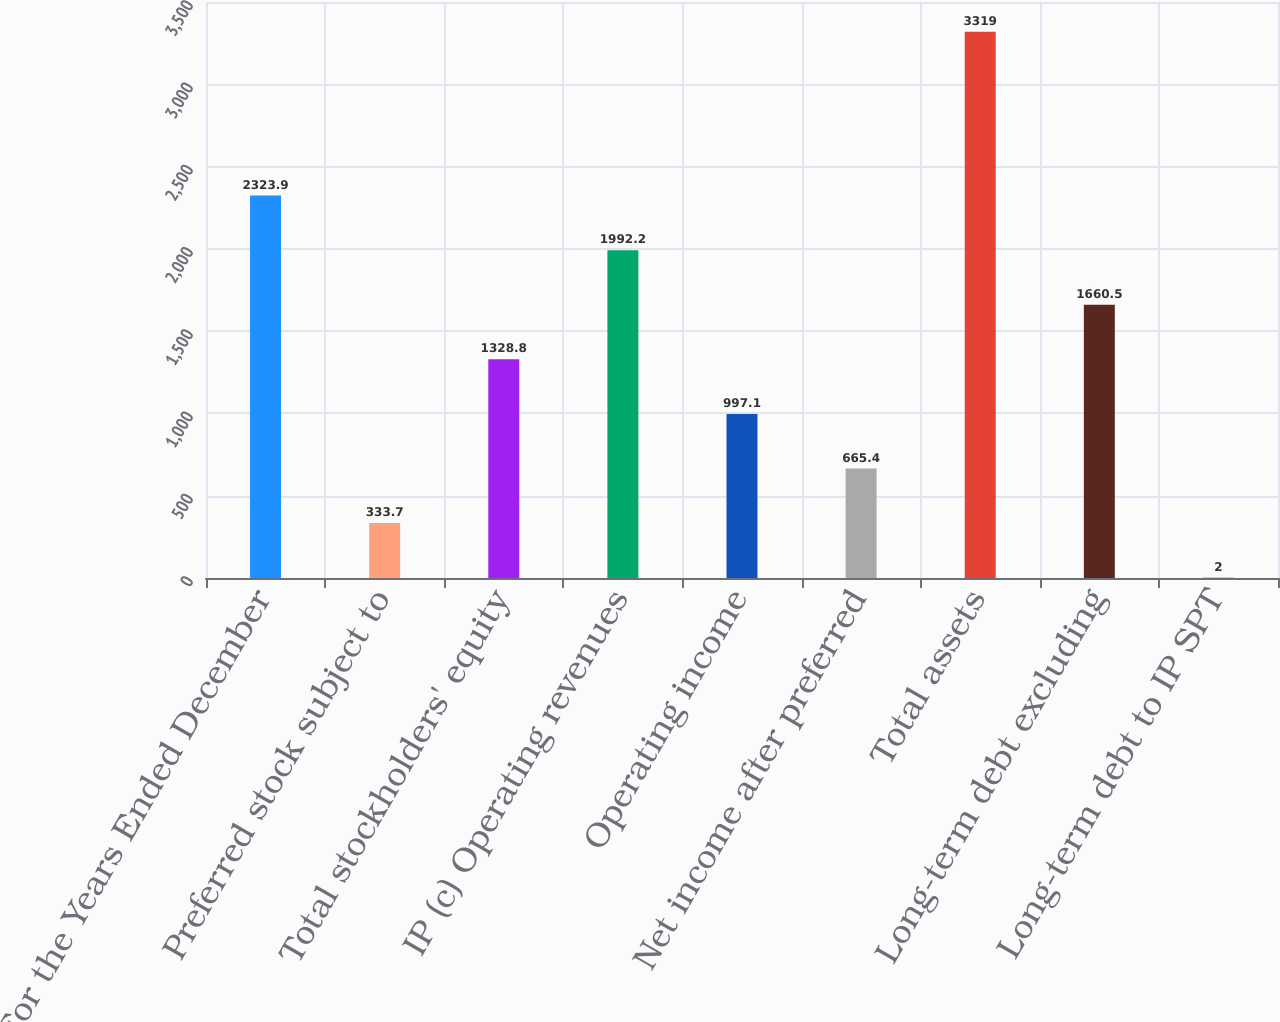Convert chart to OTSL. <chart><loc_0><loc_0><loc_500><loc_500><bar_chart><fcel>For the Years Ended December<fcel>Preferred stock subject to<fcel>Total stockholders' equity<fcel>IP (c) Operating revenues<fcel>Operating income<fcel>Net income after preferred<fcel>Total assets<fcel>Long-term debt excluding<fcel>Long-term debt to IP SPT<nl><fcel>2323.9<fcel>333.7<fcel>1328.8<fcel>1992.2<fcel>997.1<fcel>665.4<fcel>3319<fcel>1660.5<fcel>2<nl></chart> 